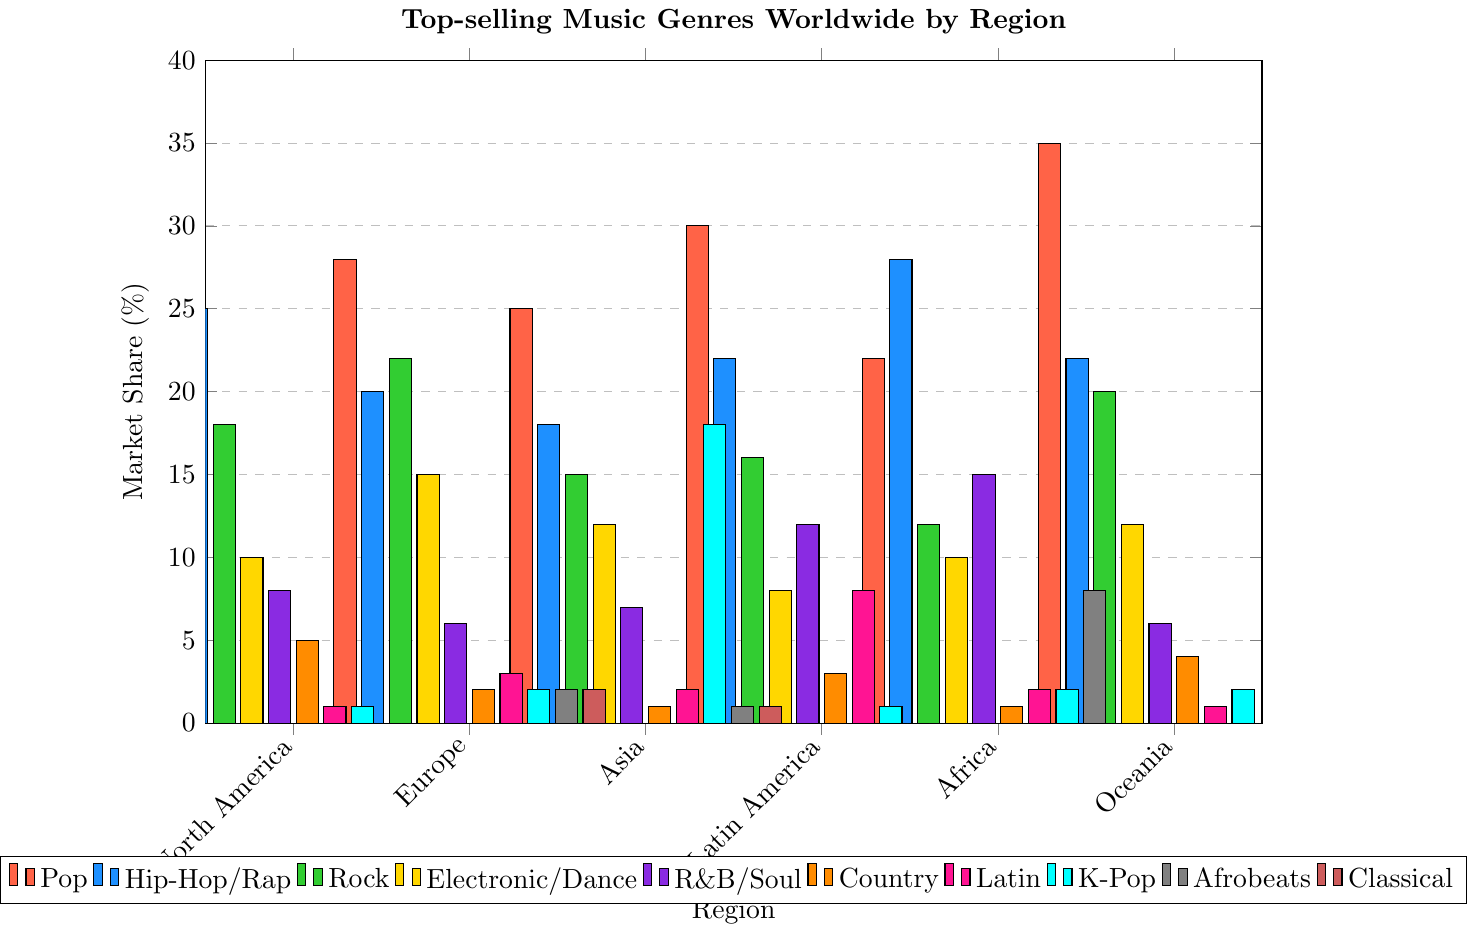What is the most popular music genre in North America? The bar representing North America is tallest for the genre Pop. Hence, Pop is the most popular genre in North America.
Answer: Pop Which genre has the highest market share in Asia? By observing the bars for Asia, K-Pop has the tallest bar, indicating it has the highest market share in Asia.
Answer: K-Pop Is Hip-Hop/Rap more popular in Africa or Oceania? Comparing the heights of the Hip-Hop/Rap bars for Africa and Oceania, the bar is taller for Africa.
Answer: Africa Which genre has the least market share in Europe? By looking at all the bars for Europe, Country has the smallest bar.
Answer: Country How does the popularity of Rock in Europe compare to North America? The bar for Rock in Europe is taller than in North America. Therefore, Rock is more popular in Europe than in North America.
Answer: Rock is more popular in Europe What is the combined market share of R&B/Soul and Electronic/Dance in Latin America? The market share of R&B/Soul in Latin America is 12, and for Electronic/Dance it is 8. Adding these together gives 12 + 8 = 20.
Answer: 20 Which region has the highest market share for Pop? The Pop bar is tallest for Oceania, indicating Oceania has the highest market share for Pop.
Answer: Oceania What is the difference in market share for Electronic/Dance between Europe and Africa? The market share for Electronic/Dance in Europe is 15, and in Africa it is 10. The difference is 15 - 10 = 5.
Answer: 5 How many genres have a market share in Africa? Counting the bars that are not zero in Africa, there are 7 genres that have a market share.
Answer: 7 What is the average market share of Country music across all regions? The market shares for Country across the regions are 5, 2, 1, 3, 1, and 4. Summing these gives 5 + 2 + 1 + 3 + 1 + 4 = 16. The average is 16 / 6 = 2.67.
Answer: 2.67 